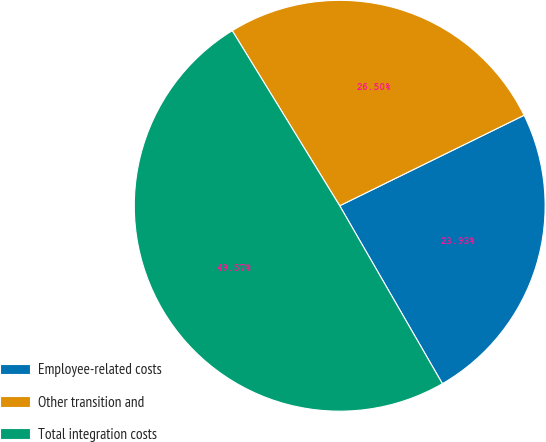Convert chart. <chart><loc_0><loc_0><loc_500><loc_500><pie_chart><fcel>Employee-related costs<fcel>Other transition and<fcel>Total integration costs<nl><fcel>23.93%<fcel>26.5%<fcel>49.57%<nl></chart> 